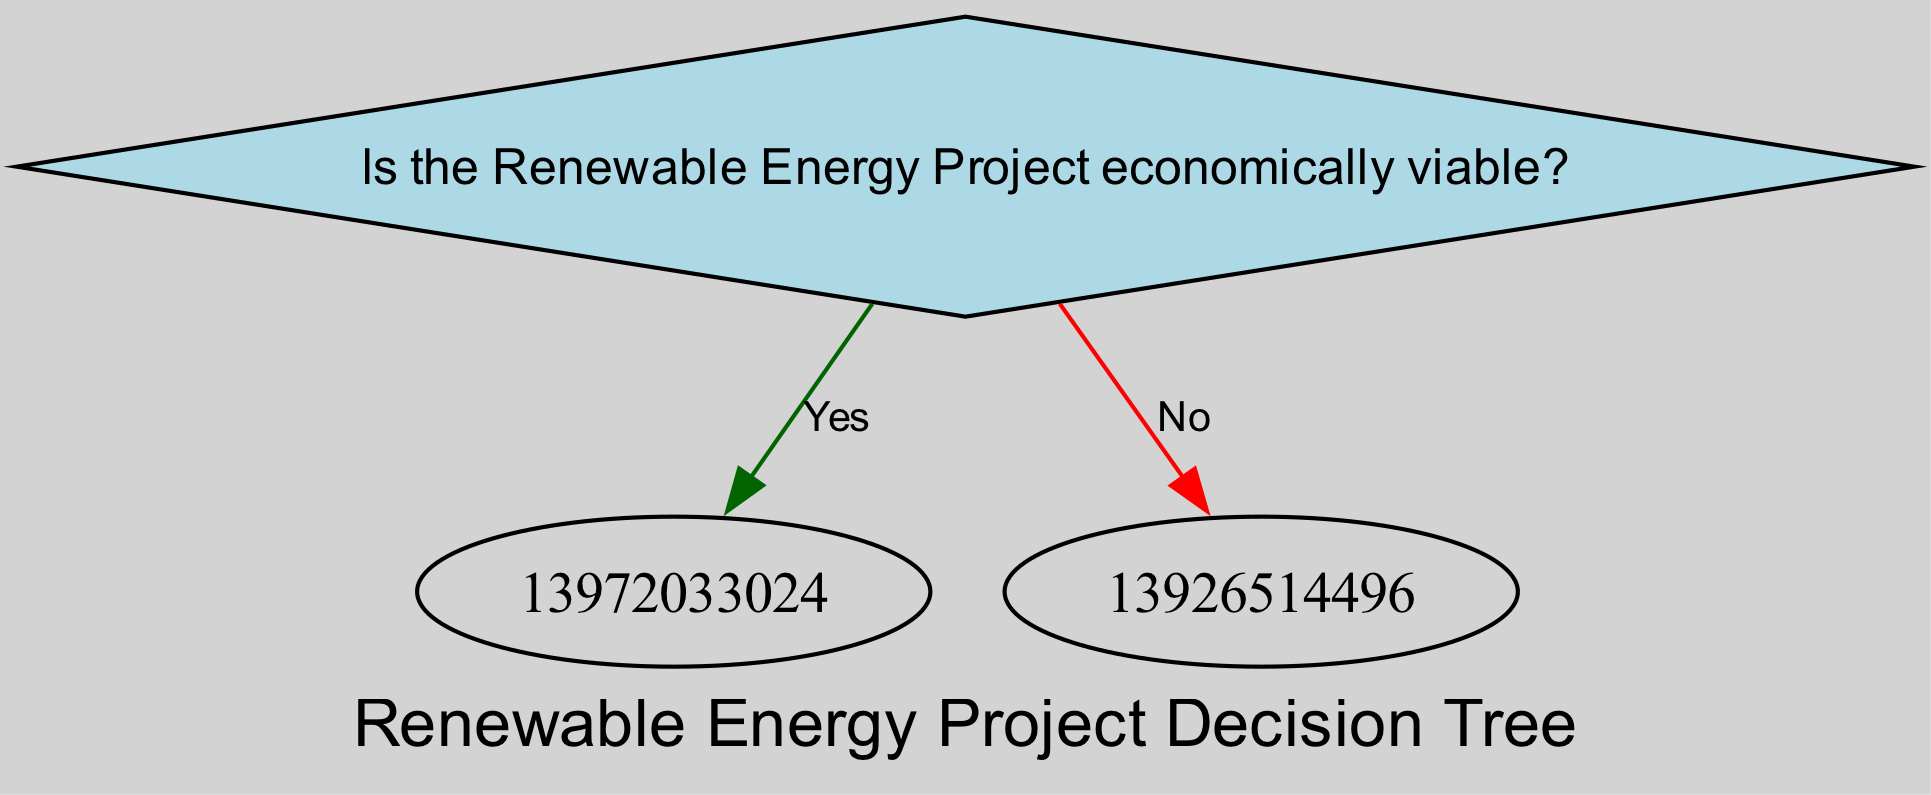Is the first question in the diagram about economic viability? The starting point of the decision tree is the initial question. By analyzing the diagram, it becomes evident that the first question asked is whether the Renewable Energy Project is economically viable.
Answer: Yes How many outcomes are there in the diagram? By examining the decision tree, I can count the distinct possible outcomes listed in the nodes. There are four outcomes represented in the tree: "Proceed with investment in project," "Consider adapting project to local energy needs," "Assess alternative financing options," and "Engage in community relationship building," and "Reassess project feasibility." Therefore, the total is five outcomes.
Answer: Five What is the second decision point after determining economic viability is yes? Working through the diagram from the initial question, if the answer is 'Yes' to economic viability, the next node asks whether there is governmental support. Therefore, this is the second decision point.
Answer: Is there governmental support? What happens if there is no governmental support? After answering 'No' to the question of governmental support, the next action recommended by the decision tree is to assess alternative financing options. This is clearly indicated as the next outcome after that node.
Answer: Assess alternative financing options What is the last question asked in the decision tree? To find the last question in the tree, I need to trace the paths that lead to the last nodes. The final question is about community support, asking "Is there community support?" This question is the last inquiry before moving to the outcomes based on its answer.
Answer: Is there community support? What leads to engaging in community relationship building? Following the flow of the decision tree, the condition leading to engaging in community relationship building occurs when the project is identified as not economically viable, there are no technological challenges, and community support exists. Therefore, the context combines these conditions for the specific action.
Answer: Community support exists How many nodes are related to the 'No' response from the economic viability question? From the diagram analysis, when the response to the economic viability question is 'No,' it leads to one subsequent question regarding technological challenges and then two possible outcomes based on whether there are technological challenges or not; hence, there are three nodes following that path.
Answer: Three nodes What alternative is suggested if the project aligns with local energy needs? If the project aligns with local energy needs after determining the project is economically viable and there is governmental support, the outcome recommended is to proceed with the investment in the project. This follows logically from the affirmative path outlined in the decision tree.
Answer: Proceed with investment in project What is the significance of the diamond shapes in the diagram? The diamond shapes indicate decision nodes or questions that require a yes or no answer, hence guiding the path to the next step in the evaluation of the Renewable Energy Projects. This is a distinctive characteristic of a decision tree, highlighting the nature of the inquiry at each stage.
Answer: Decision nodes 